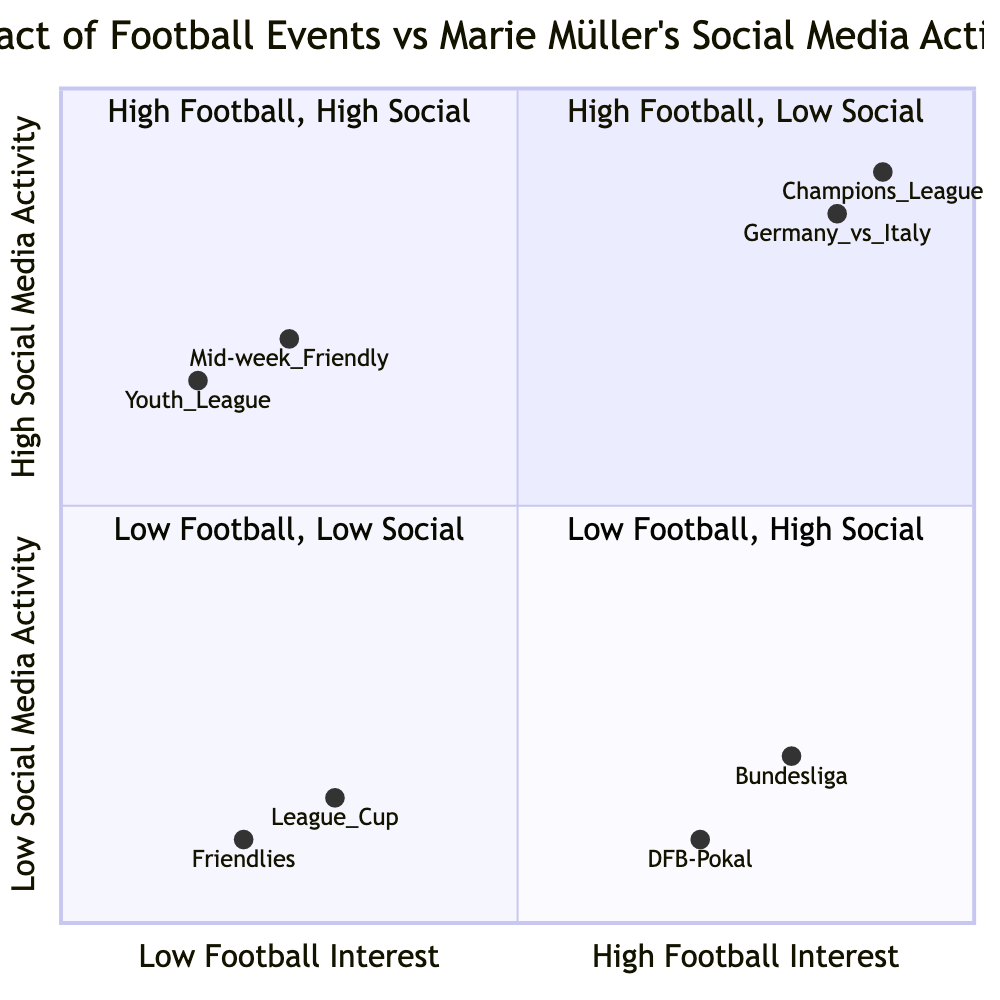What event in Q2 had the highest social media mentions? In quadrant 2 (High Football Interest, High Social Media Activity), the event "Germany vs. Italy National Match" had the highest social media mentions with 5000 mentions on Twitter.
Answer: Germany vs. Italy National Match How many events are in Q3? Quadrant 3 contains two events: "Pre-season Friendlies" and "League Cup Early Stage". Therefore, there are a total of two events in this quadrant.
Answer: 2 Which quadrant features the DFB-Pokal Finals? The DFB-Pokal Finals is listed in quadrant 1. The quadrant is characterized by high football interest and low social media activity.
Answer: Quadrant 1 What is the total number of mentions on Twitter for Q4? In quadrant 4, there are 1500 mentions for the Mid-week Friendly Matches and no additional mentions for events in this quadrant. Therefore, the total number of mentions is 1500.
Answer: 1500 Which platform had more social media activity during the UEFA Champions League Final? In quadrant 2, the UEFA Champions League Final recorded 5000 mentions on Twitter and 80 new posts on Instagram. Since 5000 mentions are more than 80 new posts, Twitter had more social media activity.
Answer: Twitter What does Q3 represent in the context of football events and social media activity? Quadrant 3 represents "Low Football Interest, Low Social Media Activity". Events in this quadrant, like Pre-season Friendlies, see fewer fans interested and minimal social media engagement.
Answer: Low Football Interest, Low Social Media Activity Which event had a mention count of 200 on Twitter? The "Bundesliga Opening Match" in quadrant 1 had 200 mentions on Twitter, indicating a specific level of social media activity despite high football interest.
Answer: Bundesliga Opening Match What is the date of the Youth League event in Q4? The Youth League event is scheduled for December 1, 2023, placing it in quadrant 4, which reflects low football interest but high social media activity.
Answer: December 1, 2023 